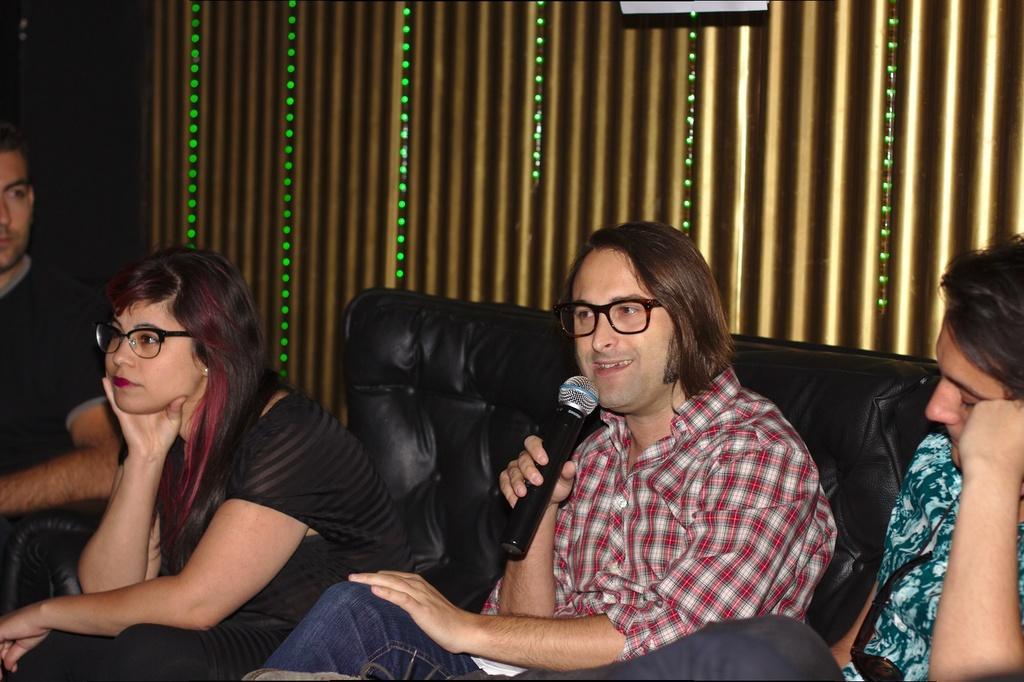Please provide a concise description of this image. In this image I can see the black colored couch and few persons sitting on the couch. I can see a person is holding a microphone in his hand. I can see few lights which are gold and green in color and the dark background. 